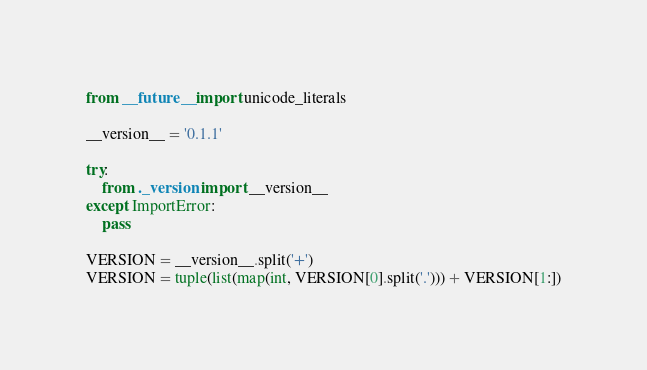Convert code to text. <code><loc_0><loc_0><loc_500><loc_500><_Python_>from __future__ import unicode_literals

__version__ = '0.1.1'

try:
    from ._version import __version__
except ImportError:
    pass

VERSION = __version__.split('+')
VERSION = tuple(list(map(int, VERSION[0].split('.'))) + VERSION[1:])
</code> 